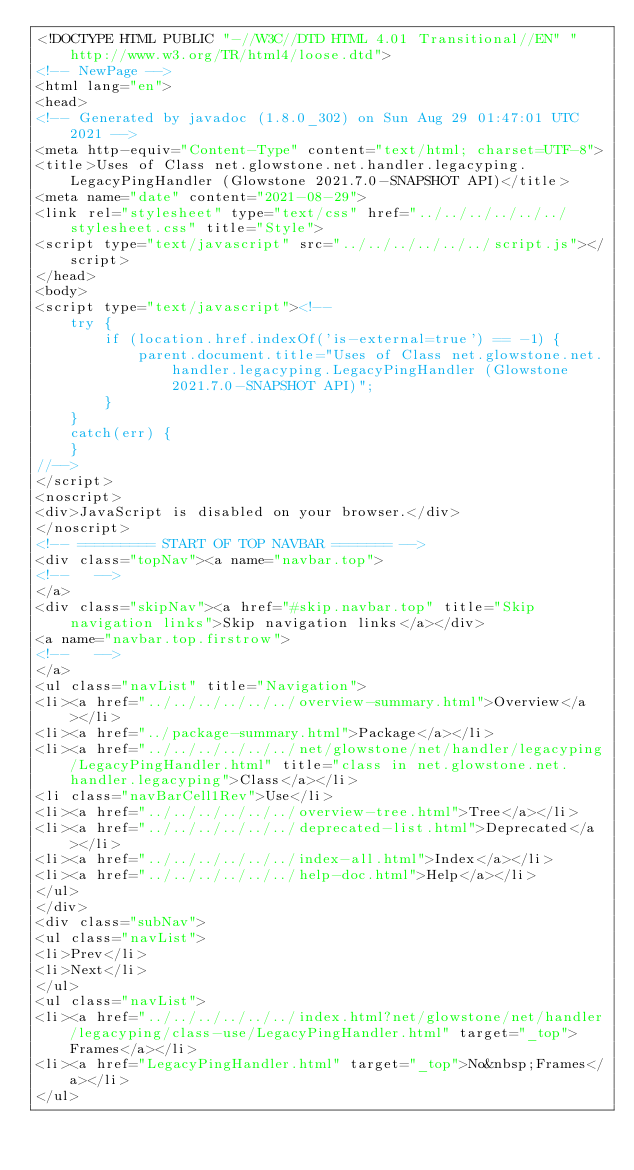<code> <loc_0><loc_0><loc_500><loc_500><_HTML_><!DOCTYPE HTML PUBLIC "-//W3C//DTD HTML 4.01 Transitional//EN" "http://www.w3.org/TR/html4/loose.dtd">
<!-- NewPage -->
<html lang="en">
<head>
<!-- Generated by javadoc (1.8.0_302) on Sun Aug 29 01:47:01 UTC 2021 -->
<meta http-equiv="Content-Type" content="text/html; charset=UTF-8">
<title>Uses of Class net.glowstone.net.handler.legacyping.LegacyPingHandler (Glowstone 2021.7.0-SNAPSHOT API)</title>
<meta name="date" content="2021-08-29">
<link rel="stylesheet" type="text/css" href="../../../../../../stylesheet.css" title="Style">
<script type="text/javascript" src="../../../../../../script.js"></script>
</head>
<body>
<script type="text/javascript"><!--
    try {
        if (location.href.indexOf('is-external=true') == -1) {
            parent.document.title="Uses of Class net.glowstone.net.handler.legacyping.LegacyPingHandler (Glowstone 2021.7.0-SNAPSHOT API)";
        }
    }
    catch(err) {
    }
//-->
</script>
<noscript>
<div>JavaScript is disabled on your browser.</div>
</noscript>
<!-- ========= START OF TOP NAVBAR ======= -->
<div class="topNav"><a name="navbar.top">
<!--   -->
</a>
<div class="skipNav"><a href="#skip.navbar.top" title="Skip navigation links">Skip navigation links</a></div>
<a name="navbar.top.firstrow">
<!--   -->
</a>
<ul class="navList" title="Navigation">
<li><a href="../../../../../../overview-summary.html">Overview</a></li>
<li><a href="../package-summary.html">Package</a></li>
<li><a href="../../../../../../net/glowstone/net/handler/legacyping/LegacyPingHandler.html" title="class in net.glowstone.net.handler.legacyping">Class</a></li>
<li class="navBarCell1Rev">Use</li>
<li><a href="../../../../../../overview-tree.html">Tree</a></li>
<li><a href="../../../../../../deprecated-list.html">Deprecated</a></li>
<li><a href="../../../../../../index-all.html">Index</a></li>
<li><a href="../../../../../../help-doc.html">Help</a></li>
</ul>
</div>
<div class="subNav">
<ul class="navList">
<li>Prev</li>
<li>Next</li>
</ul>
<ul class="navList">
<li><a href="../../../../../../index.html?net/glowstone/net/handler/legacyping/class-use/LegacyPingHandler.html" target="_top">Frames</a></li>
<li><a href="LegacyPingHandler.html" target="_top">No&nbsp;Frames</a></li>
</ul></code> 